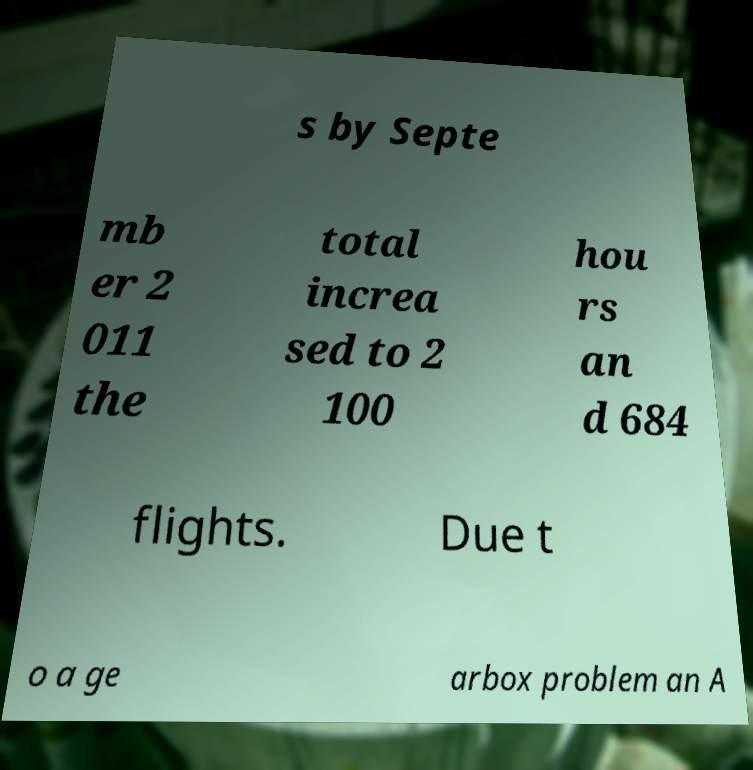Please identify and transcribe the text found in this image. s by Septe mb er 2 011 the total increa sed to 2 100 hou rs an d 684 flights. Due t o a ge arbox problem an A 